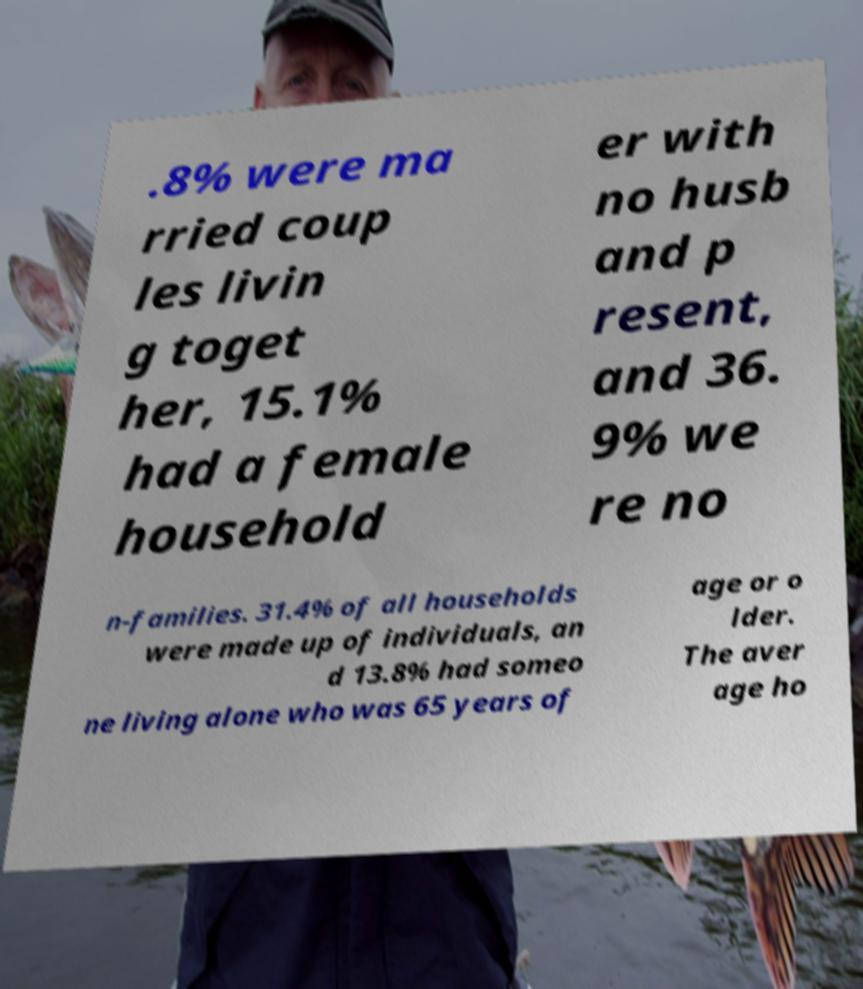For documentation purposes, I need the text within this image transcribed. Could you provide that? .8% were ma rried coup les livin g toget her, 15.1% had a female household er with no husb and p resent, and 36. 9% we re no n-families. 31.4% of all households were made up of individuals, an d 13.8% had someo ne living alone who was 65 years of age or o lder. The aver age ho 